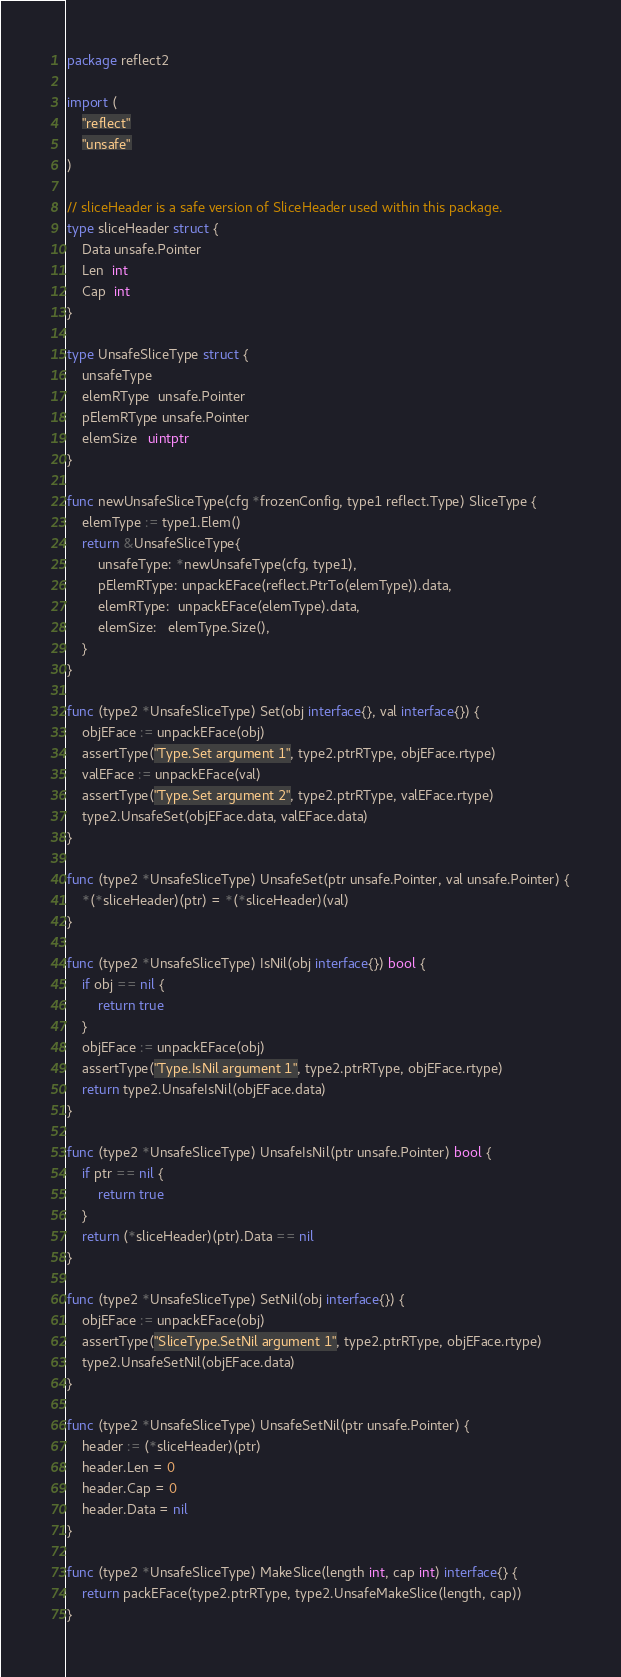Convert code to text. <code><loc_0><loc_0><loc_500><loc_500><_Go_>package reflect2

import (
	"reflect"
	"unsafe"
)

// sliceHeader is a safe version of SliceHeader used within this package.
type sliceHeader struct {
	Data unsafe.Pointer
	Len  int
	Cap  int
}

type UnsafeSliceType struct {
	unsafeType
	elemRType  unsafe.Pointer
	pElemRType unsafe.Pointer
	elemSize   uintptr
}

func newUnsafeSliceType(cfg *frozenConfig, type1 reflect.Type) SliceType {
	elemType := type1.Elem()
	return &UnsafeSliceType{
		unsafeType: *newUnsafeType(cfg, type1),
		pElemRType: unpackEFace(reflect.PtrTo(elemType)).data,
		elemRType:  unpackEFace(elemType).data,
		elemSize:   elemType.Size(),
	}
}

func (type2 *UnsafeSliceType) Set(obj interface{}, val interface{}) {
	objEFace := unpackEFace(obj)
	assertType("Type.Set argument 1", type2.ptrRType, objEFace.rtype)
	valEFace := unpackEFace(val)
	assertType("Type.Set argument 2", type2.ptrRType, valEFace.rtype)
	type2.UnsafeSet(objEFace.data, valEFace.data)
}

func (type2 *UnsafeSliceType) UnsafeSet(ptr unsafe.Pointer, val unsafe.Pointer) {
	*(*sliceHeader)(ptr) = *(*sliceHeader)(val)
}

func (type2 *UnsafeSliceType) IsNil(obj interface{}) bool {
	if obj == nil {
		return true
	}
	objEFace := unpackEFace(obj)
	assertType("Type.IsNil argument 1", type2.ptrRType, objEFace.rtype)
	return type2.UnsafeIsNil(objEFace.data)
}

func (type2 *UnsafeSliceType) UnsafeIsNil(ptr unsafe.Pointer) bool {
	if ptr == nil {
		return true
	}
	return (*sliceHeader)(ptr).Data == nil
}

func (type2 *UnsafeSliceType) SetNil(obj interface{}) {
	objEFace := unpackEFace(obj)
	assertType("SliceType.SetNil argument 1", type2.ptrRType, objEFace.rtype)
	type2.UnsafeSetNil(objEFace.data)
}

func (type2 *UnsafeSliceType) UnsafeSetNil(ptr unsafe.Pointer) {
	header := (*sliceHeader)(ptr)
	header.Len = 0
	header.Cap = 0
	header.Data = nil
}

func (type2 *UnsafeSliceType) MakeSlice(length int, cap int) interface{} {
	return packEFace(type2.ptrRType, type2.UnsafeMakeSlice(length, cap))
}
</code> 